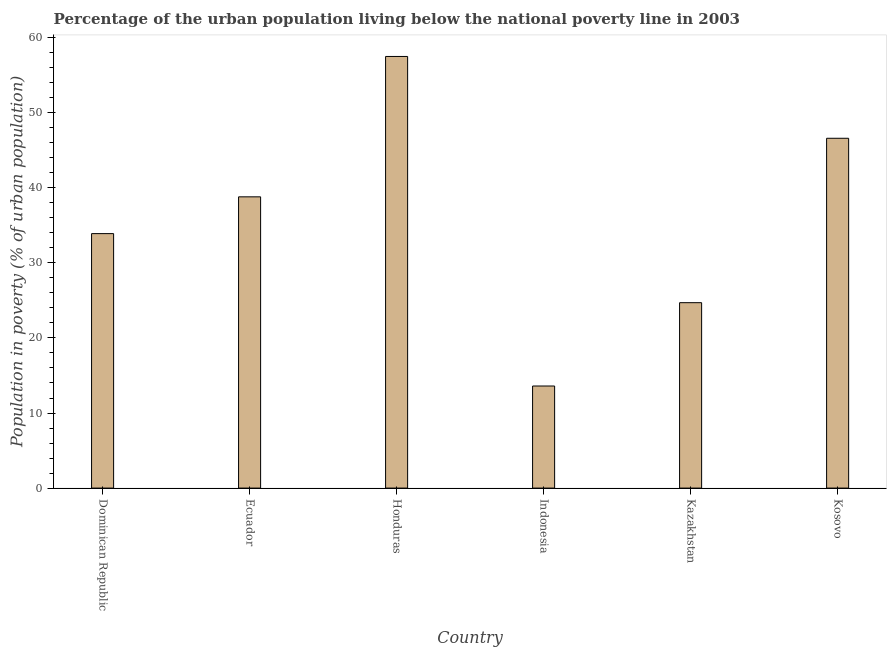Does the graph contain grids?
Offer a very short reply. No. What is the title of the graph?
Give a very brief answer. Percentage of the urban population living below the national poverty line in 2003. What is the label or title of the Y-axis?
Your answer should be compact. Population in poverty (% of urban population). What is the percentage of urban population living below poverty line in Indonesia?
Make the answer very short. 13.6. Across all countries, what is the maximum percentage of urban population living below poverty line?
Keep it short and to the point. 57.5. In which country was the percentage of urban population living below poverty line maximum?
Offer a very short reply. Honduras. In which country was the percentage of urban population living below poverty line minimum?
Offer a terse response. Indonesia. What is the sum of the percentage of urban population living below poverty line?
Your answer should be compact. 215.1. What is the difference between the percentage of urban population living below poverty line in Dominican Republic and Honduras?
Provide a succinct answer. -23.6. What is the average percentage of urban population living below poverty line per country?
Provide a succinct answer. 35.85. What is the median percentage of urban population living below poverty line?
Your response must be concise. 36.35. What is the ratio of the percentage of urban population living below poverty line in Dominican Republic to that in Ecuador?
Your response must be concise. 0.87. Is the sum of the percentage of urban population living below poverty line in Dominican Republic and Ecuador greater than the maximum percentage of urban population living below poverty line across all countries?
Offer a terse response. Yes. What is the difference between the highest and the lowest percentage of urban population living below poverty line?
Provide a succinct answer. 43.9. What is the Population in poverty (% of urban population) in Dominican Republic?
Your answer should be compact. 33.9. What is the Population in poverty (% of urban population) in Ecuador?
Provide a succinct answer. 38.8. What is the Population in poverty (% of urban population) of Honduras?
Ensure brevity in your answer.  57.5. What is the Population in poverty (% of urban population) of Indonesia?
Your response must be concise. 13.6. What is the Population in poverty (% of urban population) of Kazakhstan?
Make the answer very short. 24.7. What is the Population in poverty (% of urban population) in Kosovo?
Offer a terse response. 46.6. What is the difference between the Population in poverty (% of urban population) in Dominican Republic and Ecuador?
Make the answer very short. -4.9. What is the difference between the Population in poverty (% of urban population) in Dominican Republic and Honduras?
Your answer should be very brief. -23.6. What is the difference between the Population in poverty (% of urban population) in Dominican Republic and Indonesia?
Make the answer very short. 20.3. What is the difference between the Population in poverty (% of urban population) in Dominican Republic and Kosovo?
Your answer should be very brief. -12.7. What is the difference between the Population in poverty (% of urban population) in Ecuador and Honduras?
Your answer should be compact. -18.7. What is the difference between the Population in poverty (% of urban population) in Ecuador and Indonesia?
Keep it short and to the point. 25.2. What is the difference between the Population in poverty (% of urban population) in Ecuador and Kazakhstan?
Give a very brief answer. 14.1. What is the difference between the Population in poverty (% of urban population) in Honduras and Indonesia?
Your answer should be compact. 43.9. What is the difference between the Population in poverty (% of urban population) in Honduras and Kazakhstan?
Provide a short and direct response. 32.8. What is the difference between the Population in poverty (% of urban population) in Indonesia and Kosovo?
Your answer should be very brief. -33. What is the difference between the Population in poverty (% of urban population) in Kazakhstan and Kosovo?
Make the answer very short. -21.9. What is the ratio of the Population in poverty (% of urban population) in Dominican Republic to that in Ecuador?
Offer a terse response. 0.87. What is the ratio of the Population in poverty (% of urban population) in Dominican Republic to that in Honduras?
Provide a succinct answer. 0.59. What is the ratio of the Population in poverty (% of urban population) in Dominican Republic to that in Indonesia?
Offer a very short reply. 2.49. What is the ratio of the Population in poverty (% of urban population) in Dominican Republic to that in Kazakhstan?
Offer a terse response. 1.37. What is the ratio of the Population in poverty (% of urban population) in Dominican Republic to that in Kosovo?
Make the answer very short. 0.73. What is the ratio of the Population in poverty (% of urban population) in Ecuador to that in Honduras?
Give a very brief answer. 0.68. What is the ratio of the Population in poverty (% of urban population) in Ecuador to that in Indonesia?
Your answer should be compact. 2.85. What is the ratio of the Population in poverty (% of urban population) in Ecuador to that in Kazakhstan?
Ensure brevity in your answer.  1.57. What is the ratio of the Population in poverty (% of urban population) in Ecuador to that in Kosovo?
Offer a very short reply. 0.83. What is the ratio of the Population in poverty (% of urban population) in Honduras to that in Indonesia?
Make the answer very short. 4.23. What is the ratio of the Population in poverty (% of urban population) in Honduras to that in Kazakhstan?
Your response must be concise. 2.33. What is the ratio of the Population in poverty (% of urban population) in Honduras to that in Kosovo?
Your answer should be very brief. 1.23. What is the ratio of the Population in poverty (% of urban population) in Indonesia to that in Kazakhstan?
Your response must be concise. 0.55. What is the ratio of the Population in poverty (% of urban population) in Indonesia to that in Kosovo?
Your response must be concise. 0.29. What is the ratio of the Population in poverty (% of urban population) in Kazakhstan to that in Kosovo?
Ensure brevity in your answer.  0.53. 